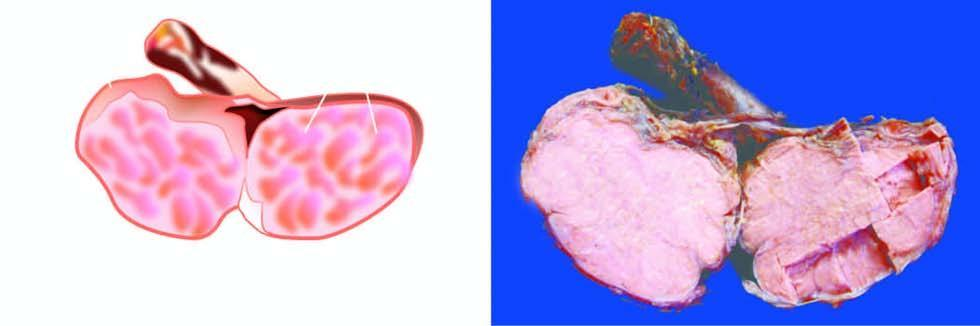what does sectioned surface show?
Answer the question using a single word or phrase. Replacement of the entire testis by lobulated 